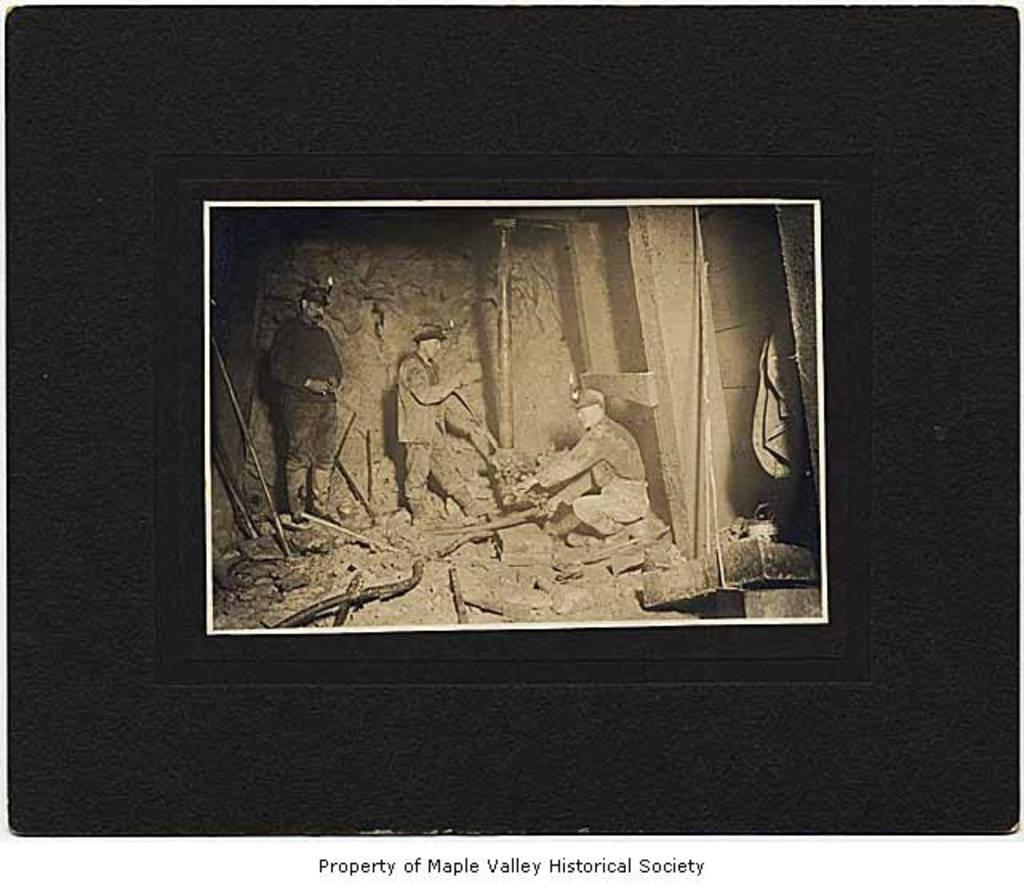What is the main subject of the image? There is a photograph in the image. What can be seen in the photograph? The photograph contains people, one of whom is sitting. What other elements are present in the photograph? There are poles, stones, and other objects in the photograph. How many planes can be seen flying in the photograph? There are no planes visible in the photograph; it only contains people, poles, stones, and other objects. Is there a trampoline visible in the photograph? There is no trampoline present in the photograph. 